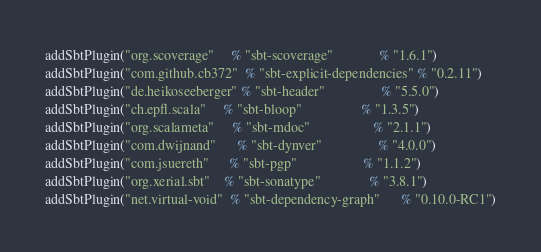<code> <loc_0><loc_0><loc_500><loc_500><_Scala_>addSbtPlugin("org.scoverage"     % "sbt-scoverage"             % "1.6.1")
addSbtPlugin("com.github.cb372"  % "sbt-explicit-dependencies" % "0.2.11")
addSbtPlugin("de.heikoseeberger" % "sbt-header"                % "5.5.0")
addSbtPlugin("ch.epfl.scala"     % "sbt-bloop"                 % "1.3.5")
addSbtPlugin("org.scalameta"     % "sbt-mdoc"                  % "2.1.1")
addSbtPlugin("com.dwijnand"      % "sbt-dynver"                % "4.0.0")
addSbtPlugin("com.jsuereth"      % "sbt-pgp"                   % "1.1.2")
addSbtPlugin("org.xerial.sbt"    % "sbt-sonatype"              % "3.8.1")
addSbtPlugin("net.virtual-void"  % "sbt-dependency-graph"      % "0.10.0-RC1")
</code> 